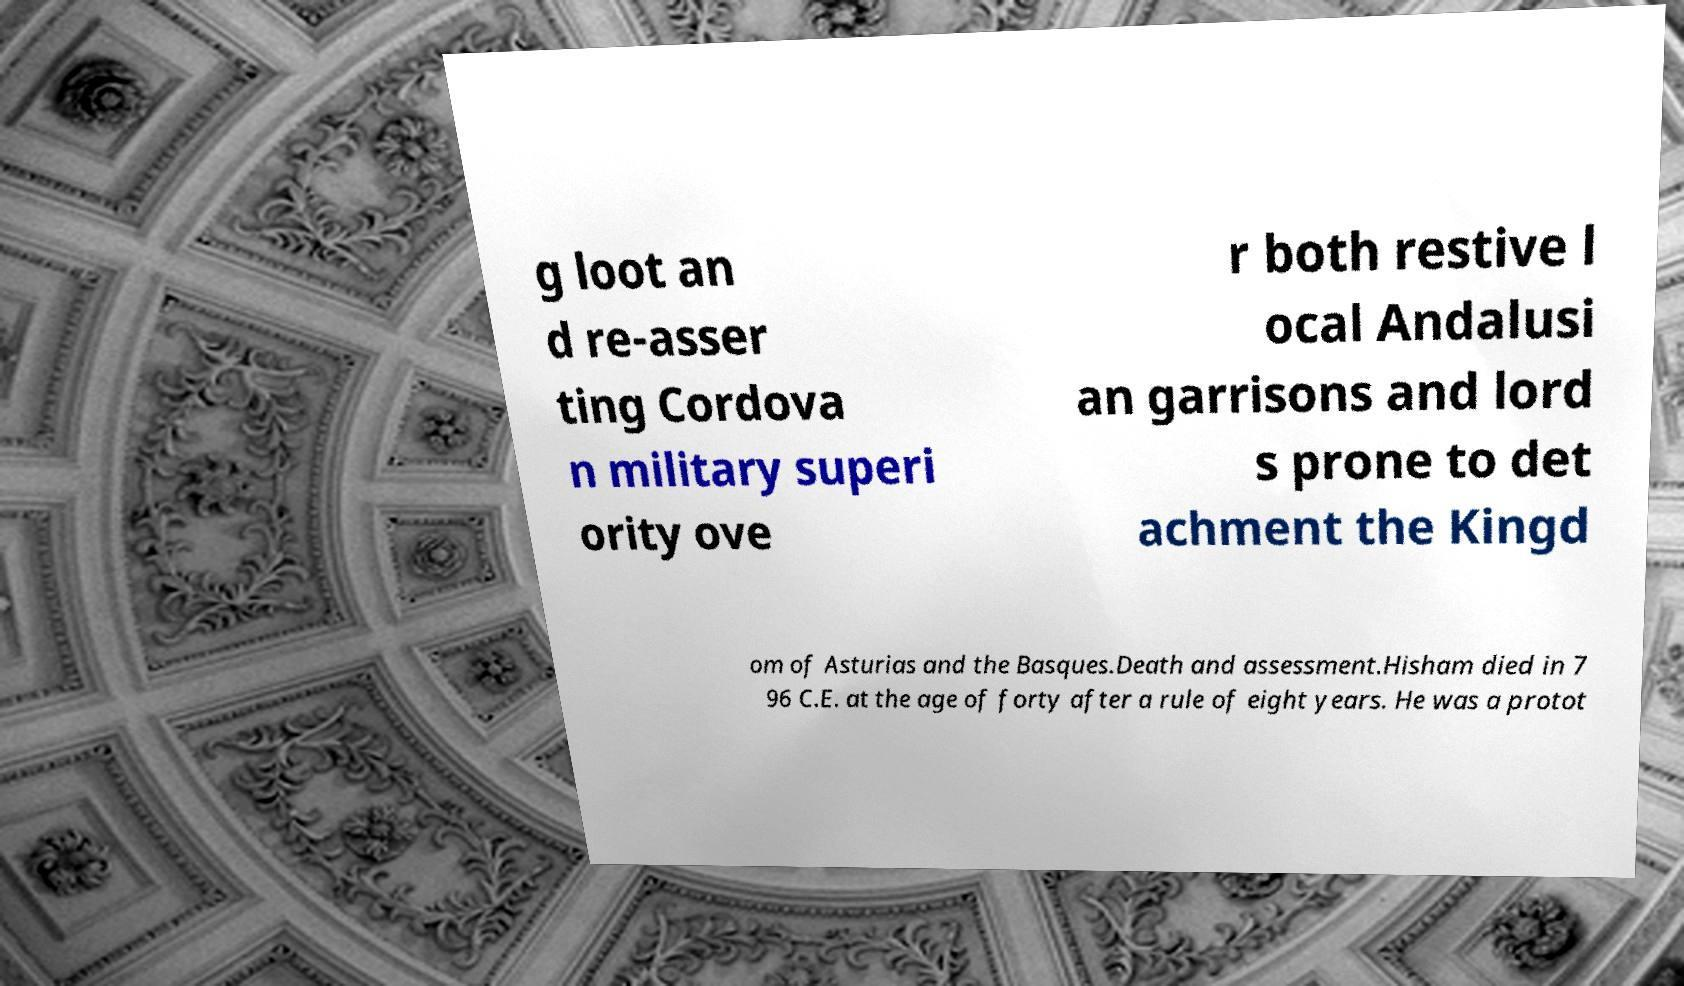Please identify and transcribe the text found in this image. g loot an d re-asser ting Cordova n military superi ority ove r both restive l ocal Andalusi an garrisons and lord s prone to det achment the Kingd om of Asturias and the Basques.Death and assessment.Hisham died in 7 96 C.E. at the age of forty after a rule of eight years. He was a protot 